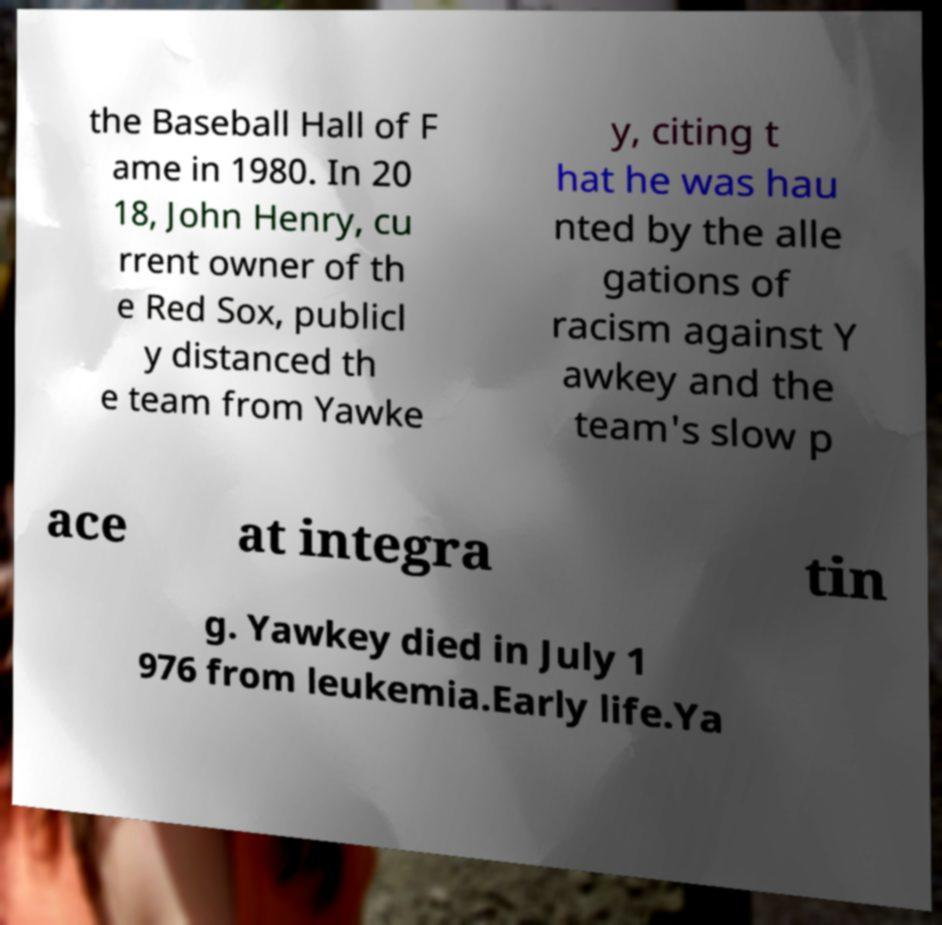Please identify and transcribe the text found in this image. the Baseball Hall of F ame in 1980. In 20 18, John Henry, cu rrent owner of th e Red Sox, publicl y distanced th e team from Yawke y, citing t hat he was hau nted by the alle gations of racism against Y awkey and the team's slow p ace at integra tin g. Yawkey died in July 1 976 from leukemia.Early life.Ya 